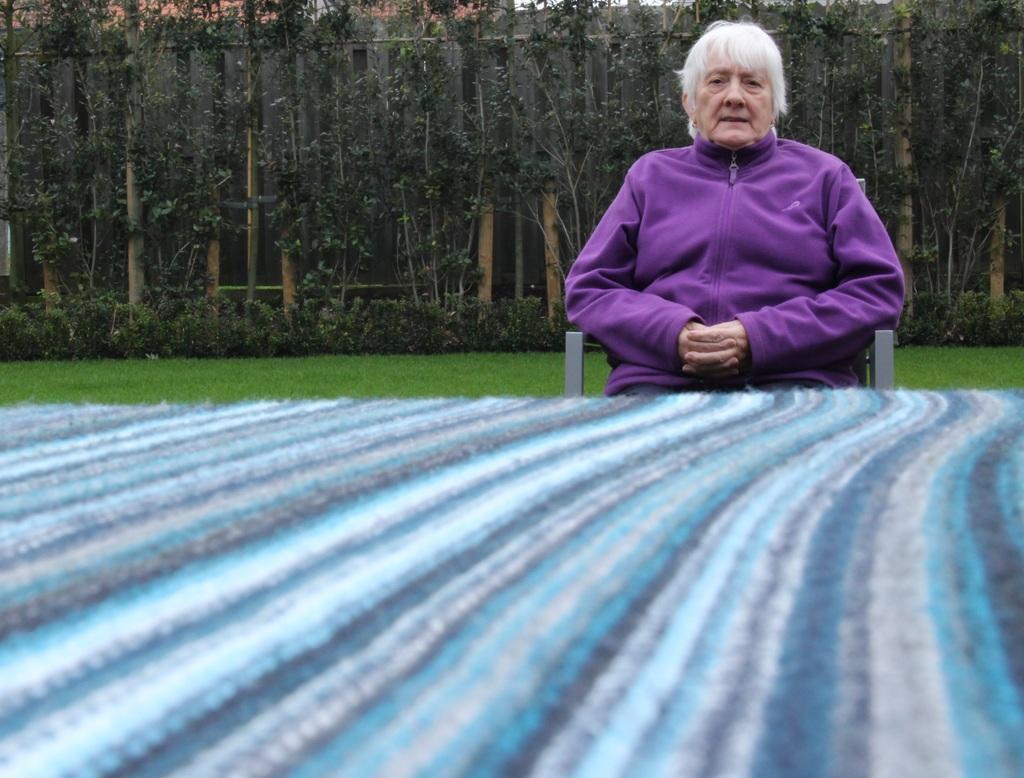Could you give a brief overview of what you see in this image? In this image I can see a person sitting on the chair and wearing purple color dress. Back I can see trees. In front I can see a multi-color board. 